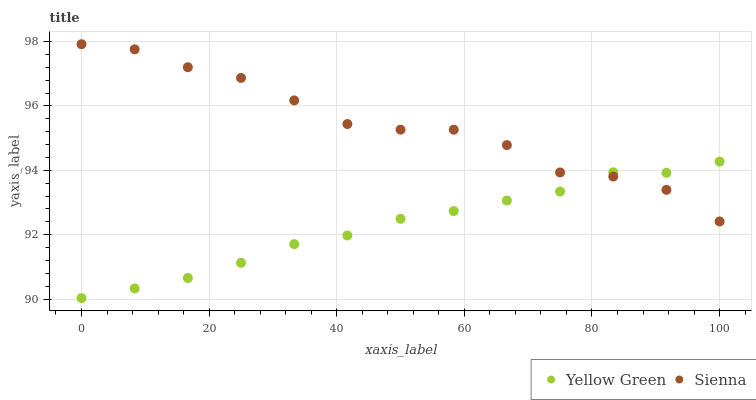Does Yellow Green have the minimum area under the curve?
Answer yes or no. Yes. Does Sienna have the maximum area under the curve?
Answer yes or no. Yes. Does Yellow Green have the maximum area under the curve?
Answer yes or no. No. Is Yellow Green the smoothest?
Answer yes or no. Yes. Is Sienna the roughest?
Answer yes or no. Yes. Is Yellow Green the roughest?
Answer yes or no. No. Does Yellow Green have the lowest value?
Answer yes or no. Yes. Does Sienna have the highest value?
Answer yes or no. Yes. Does Yellow Green have the highest value?
Answer yes or no. No. Does Yellow Green intersect Sienna?
Answer yes or no. Yes. Is Yellow Green less than Sienna?
Answer yes or no. No. Is Yellow Green greater than Sienna?
Answer yes or no. No. 